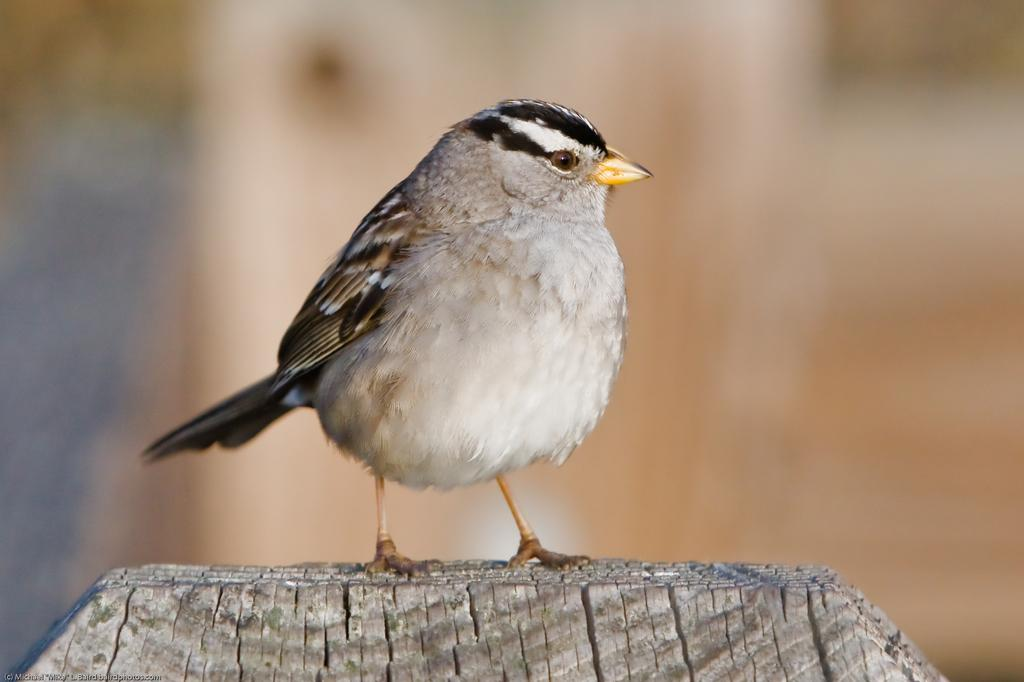What type of animal is in the image? There is a bird in the image. What is the bird perched on? The bird is on a wooden object. Can you describe the background of the image? The background of the image is blurred. Is there any additional information or markings on the image? Yes, there is a watermark on the image. How many kittens are waving good-bye in the image? There are no kittens or any good-bye gestures present in the image. 